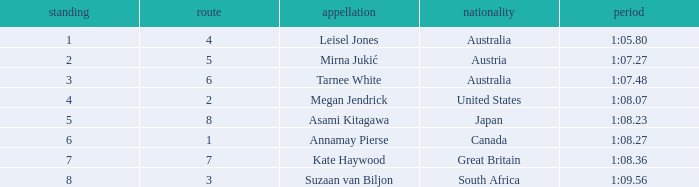What is the Nationality of the Swimmer in Lane 4 or larger with a Rank of 5 or more? Great Britain. 